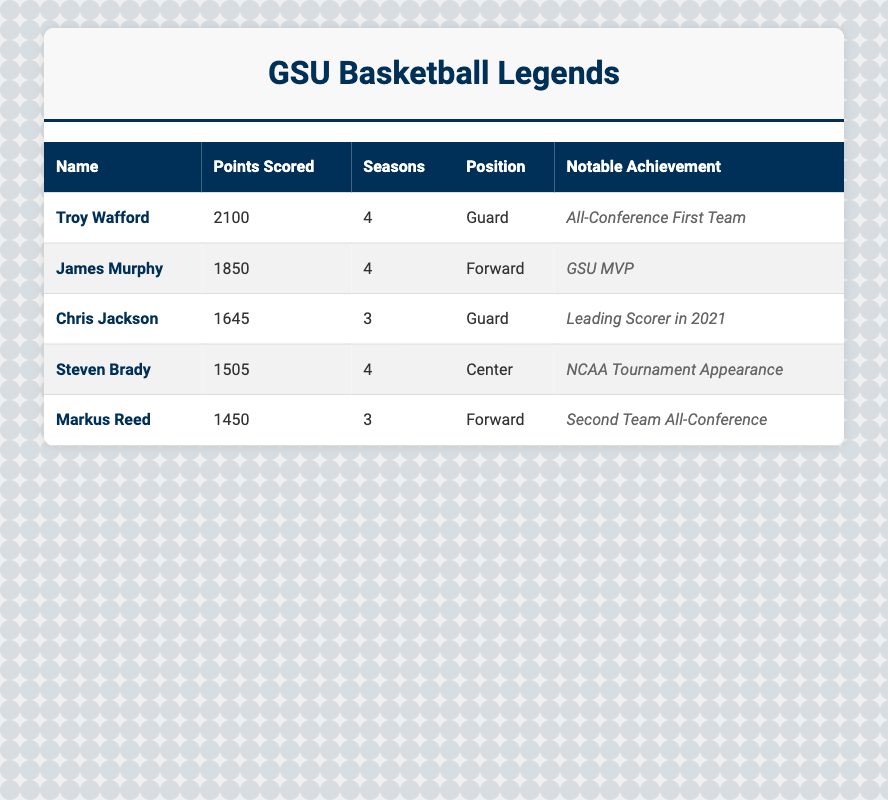What is the highest number of points scored by a player? By scanning the table, the player's name with the most points scored is highlighted, which is Troy Wafford with 2100 points.
Answer: 2100 How many seasons did James Murphy play? The table shows James Murphy's entry, indicating he played for 4 seasons.
Answer: 4 Who achieved the notable accolade of GSU MVP? The table lists James Murphy’s notable achievement as "GSU MVP," confirming he received this accolade.
Answer: James Murphy How many points did Steven Brady score? The table indicates that Steven Brady scored a total of 1505 points.
Answer: 1505 What is the average number of points scored by the top players listed in the table? To find the average, add the points: (2100 + 1850 + 1645 + 1505 + 1450) = 10250. Then divide by 5 players: 10250 / 5 = 2050.
Answer: 2050 Which player is the only Center in the list? Looking at the table, Steven Brady is the only player with the position listed as Center.
Answer: Steven Brady Is there a player with fewer than 1500 points scored? The table shows that Markus Reed has 1450 points, indicating he scored fewer than 1500 points.
Answer: Yes Calculate the difference in points scored between the top player and the third top player. The top player, Troy Wafford, has 2100 points, and Chris Jackson, the third top player, has 1645 points. The difference is 2100 - 1645 = 455.
Answer: 455 How many players listed played for 3 seasons? The table shows Chris Jackson and Markus Reed both played for 3 seasons, indicating there are 2 players in this category.
Answer: 2 What position did the second highest scorer play? The second highest scorer, James Murphy, is listed as a Forward in the table.
Answer: Forward 